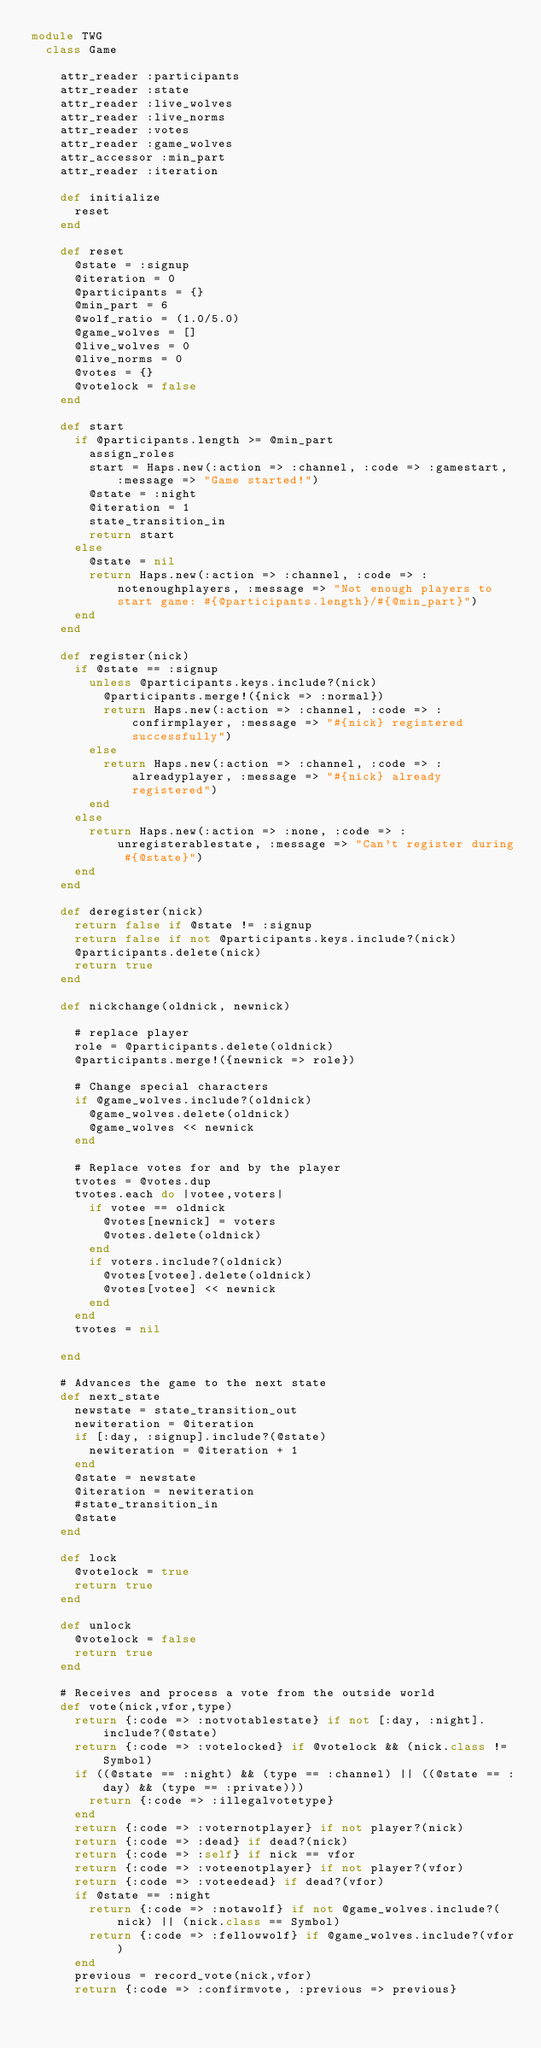<code> <loc_0><loc_0><loc_500><loc_500><_Ruby_>module TWG
  class Game

    attr_reader :participants
    attr_reader :state
    attr_reader :live_wolves
    attr_reader :live_norms
    attr_reader :votes
    attr_reader :game_wolves
    attr_accessor :min_part
    attr_reader :iteration

    def initialize
      reset
    end

    def reset
      @state = :signup
      @iteration = 0
      @participants = {}
      @min_part = 6
      @wolf_ratio = (1.0/5.0)
      @game_wolves = []
      @live_wolves = 0
      @live_norms = 0
      @votes = {}
      @votelock = false
    end

    def start
      if @participants.length >= @min_part
        assign_roles
        start = Haps.new(:action => :channel, :code => :gamestart, :message => "Game started!")
        @state = :night
        @iteration = 1
        state_transition_in
        return start
      else
        @state = nil
        return Haps.new(:action => :channel, :code => :notenoughplayers, :message => "Not enough players to start game: #{@participants.length}/#{@min_part}")
      end
    end

    def register(nick)
      if @state == :signup
        unless @participants.keys.include?(nick)
          @participants.merge!({nick => :normal})
          return Haps.new(:action => :channel, :code => :confirmplayer, :message => "#{nick} registered successfully")
        else
          return Haps.new(:action => :channel, :code => :alreadyplayer, :message => "#{nick} already registered")
        end
      else
        return Haps.new(:action => :none, :code => :unregisterablestate, :message => "Can't register during #{@state}")
      end
    end

    def deregister(nick)
      return false if @state != :signup
      return false if not @participants.keys.include?(nick)
      @participants.delete(nick)
      return true
    end

    def nickchange(oldnick, newnick)

      # replace player
      role = @participants.delete(oldnick)
      @participants.merge!({newnick => role})

      # Change special characters
      if @game_wolves.include?(oldnick)
        @game_wolves.delete(oldnick)
        @game_wolves << newnick
      end

      # Replace votes for and by the player
      tvotes = @votes.dup
      tvotes.each do |votee,voters|
        if votee == oldnick
          @votes[newnick] = voters
          @votes.delete(oldnick)
        end
        if voters.include?(oldnick)
          @votes[votee].delete(oldnick)
          @votes[votee] << newnick
        end
      end
      tvotes = nil

    end

    # Advances the game to the next state
    def next_state
      newstate = state_transition_out
      newiteration = @iteration
      if [:day, :signup].include?(@state)
        newiteration = @iteration + 1
      end
      @state = newstate
      @iteration = newiteration
      #state_transition_in
      @state
    end

    def lock
      @votelock = true
      return true
    end

    def unlock
      @votelock = false
      return true
    end

    # Receives and process a vote from the outside world
    def vote(nick,vfor,type)
      return {:code => :notvotablestate} if not [:day, :night].include?(@state)
      return {:code => :votelocked} if @votelock && (nick.class != Symbol)
      if ((@state == :night) && (type == :channel) || ((@state == :day) && (type == :private)))
        return {:code => :illegalvotetype}
      end
      return {:code => :voternotplayer} if not player?(nick)
      return {:code => :dead} if dead?(nick)
      return {:code => :self} if nick == vfor
      return {:code => :voteenotplayer} if not player?(vfor)
      return {:code => :voteedead} if dead?(vfor)
      if @state == :night
        return {:code => :notawolf} if not @game_wolves.include?(nick) || (nick.class == Symbol)
        return {:code => :fellowwolf} if @game_wolves.include?(vfor)
      end
      previous = record_vote(nick,vfor)
      return {:code => :confirmvote, :previous => previous}</code> 